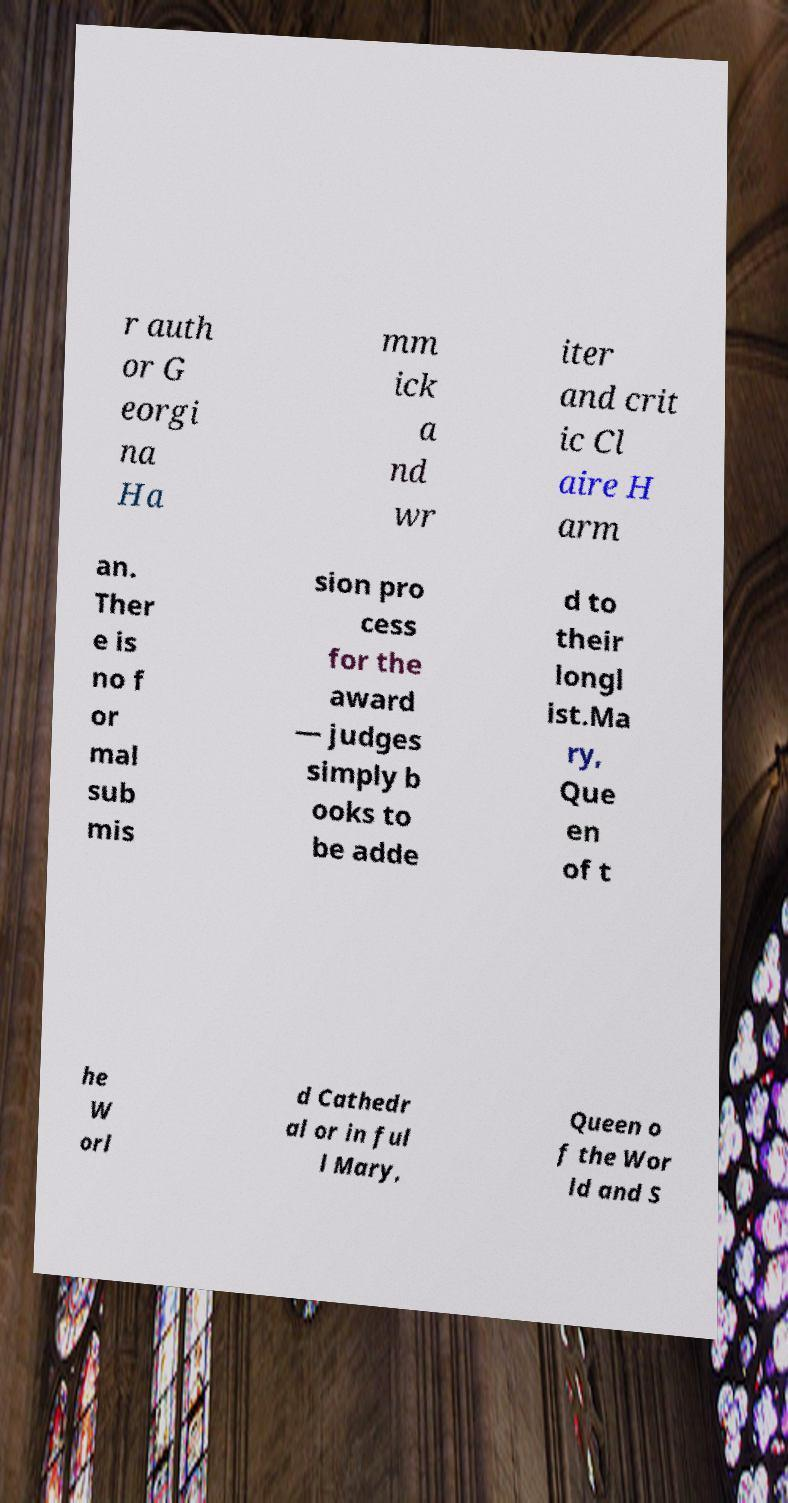Please read and relay the text visible in this image. What does it say? r auth or G eorgi na Ha mm ick a nd wr iter and crit ic Cl aire H arm an. Ther e is no f or mal sub mis sion pro cess for the award — judges simply b ooks to be adde d to their longl ist.Ma ry, Que en of t he W orl d Cathedr al or in ful l Mary, Queen o f the Wor ld and S 